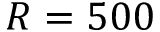<formula> <loc_0><loc_0><loc_500><loc_500>R = 5 0 0</formula> 